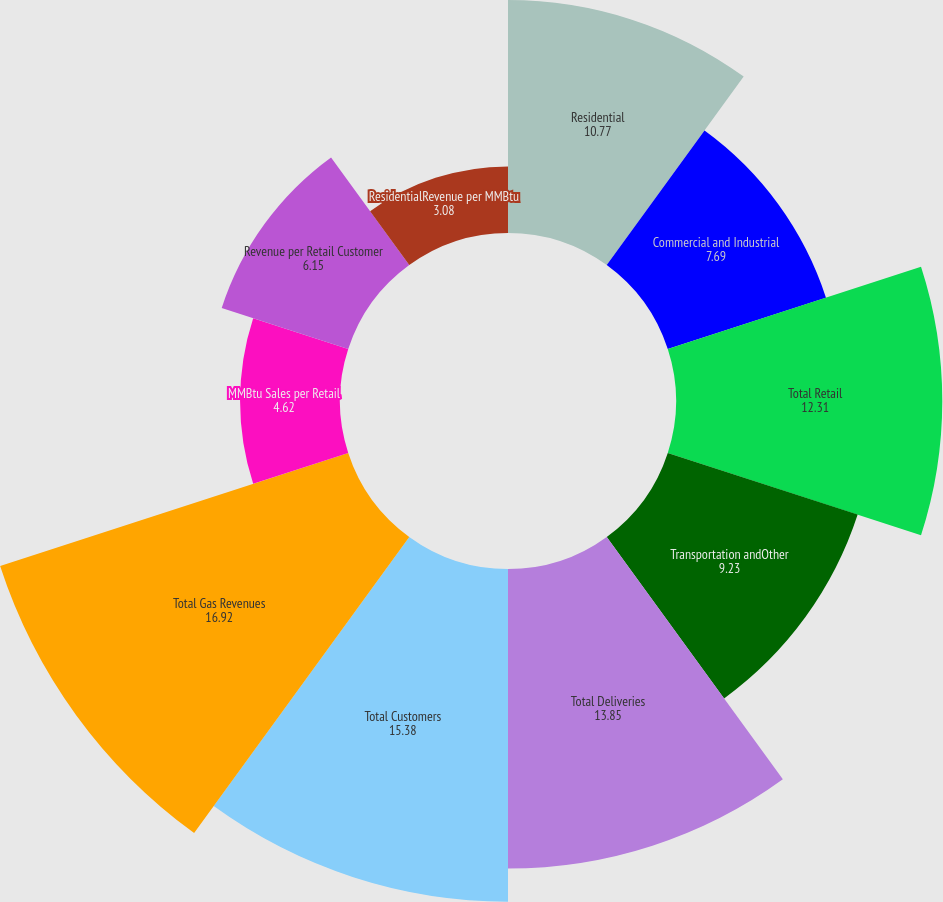Convert chart. <chart><loc_0><loc_0><loc_500><loc_500><pie_chart><fcel>Residential<fcel>Commercial and Industrial<fcel>Total Retail<fcel>Transportation andOther<fcel>Total Deliveries<fcel>Total Customers<fcel>Total Gas Revenues<fcel>MMBtu Sales per Retail<fcel>Revenue per Retail Customer<fcel>ResidentialRevenue per MMBtu<nl><fcel>10.77%<fcel>7.69%<fcel>12.31%<fcel>9.23%<fcel>13.85%<fcel>15.38%<fcel>16.92%<fcel>4.62%<fcel>6.15%<fcel>3.08%<nl></chart> 